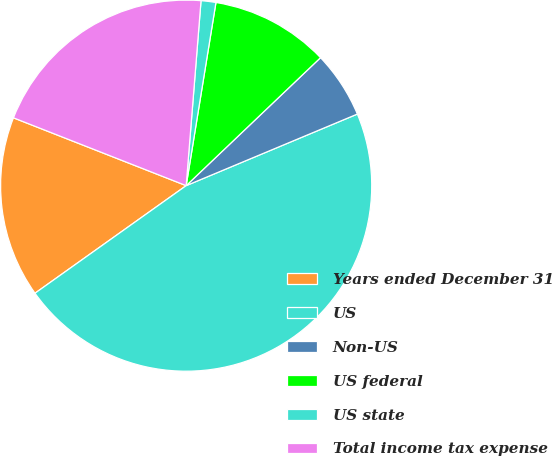<chart> <loc_0><loc_0><loc_500><loc_500><pie_chart><fcel>Years ended December 31<fcel>US<fcel>Non-US<fcel>US federal<fcel>US state<fcel>Total income tax expense<nl><fcel>15.8%<fcel>46.46%<fcel>5.81%<fcel>10.32%<fcel>1.29%<fcel>20.32%<nl></chart> 